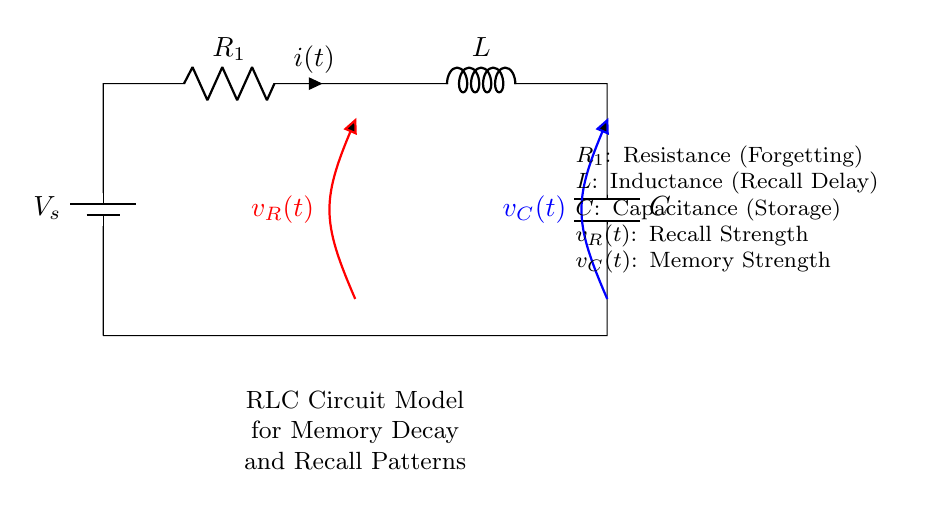What is the voltage source in this circuit? The voltage source in the circuit is labeled as \(V_s\), which is the source providing electrical energy to the circuit.
Answer: \(V_s\) What does the symbol \(R_1\) represent? The symbol \(R_1\) represents resistance, which relates to forgetting in the context of the memory decay model.
Answer: Resistance What is the role of the inductor \(L\) in this circuit? The inductor \(L\) represents a delay in recall, indicating how inductive effects impact memory retrieval over time.
Answer: Recall Delay What are the voltage labels for the resistor and capacitor? The voltage across the resistor is labeled \(v_R(t)\), while the voltage across the capacitor is labeled \(v_C(t)\).
Answer: \(v_R(t), v_C(t)\) If the capacitance \(C\) is increased, how would that affect memory strength? Increasing capacitance \(C\) allows for greater storage of memory, potentially enhancing the strength of recall over time, as indicated by its role in the model.
Answer: Increases strength How does the resistance \(R_1\) affect memory decay? Increasing resistance \(R_1\) will lead to faster forgetting or decay of memory, showing a direct relationship between resistance and memory loss.
Answer: Faster forgetting What does \(v_C(t)\) represent in this circuit? \(v_C(t)\) represents memory strength, which is the voltage across the capacitor and signifies the stored information in the memory decay model.
Answer: Memory Strength 